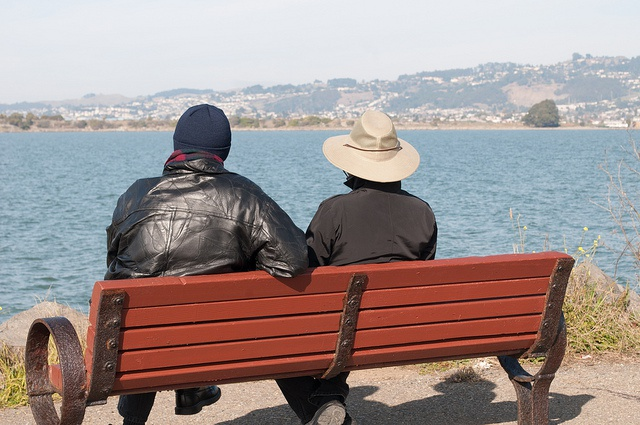Describe the objects in this image and their specific colors. I can see bench in lightgray, brown, maroon, and black tones, people in lightgray, gray, black, and darkgray tones, and people in lightgray, black, beige, and tan tones in this image. 